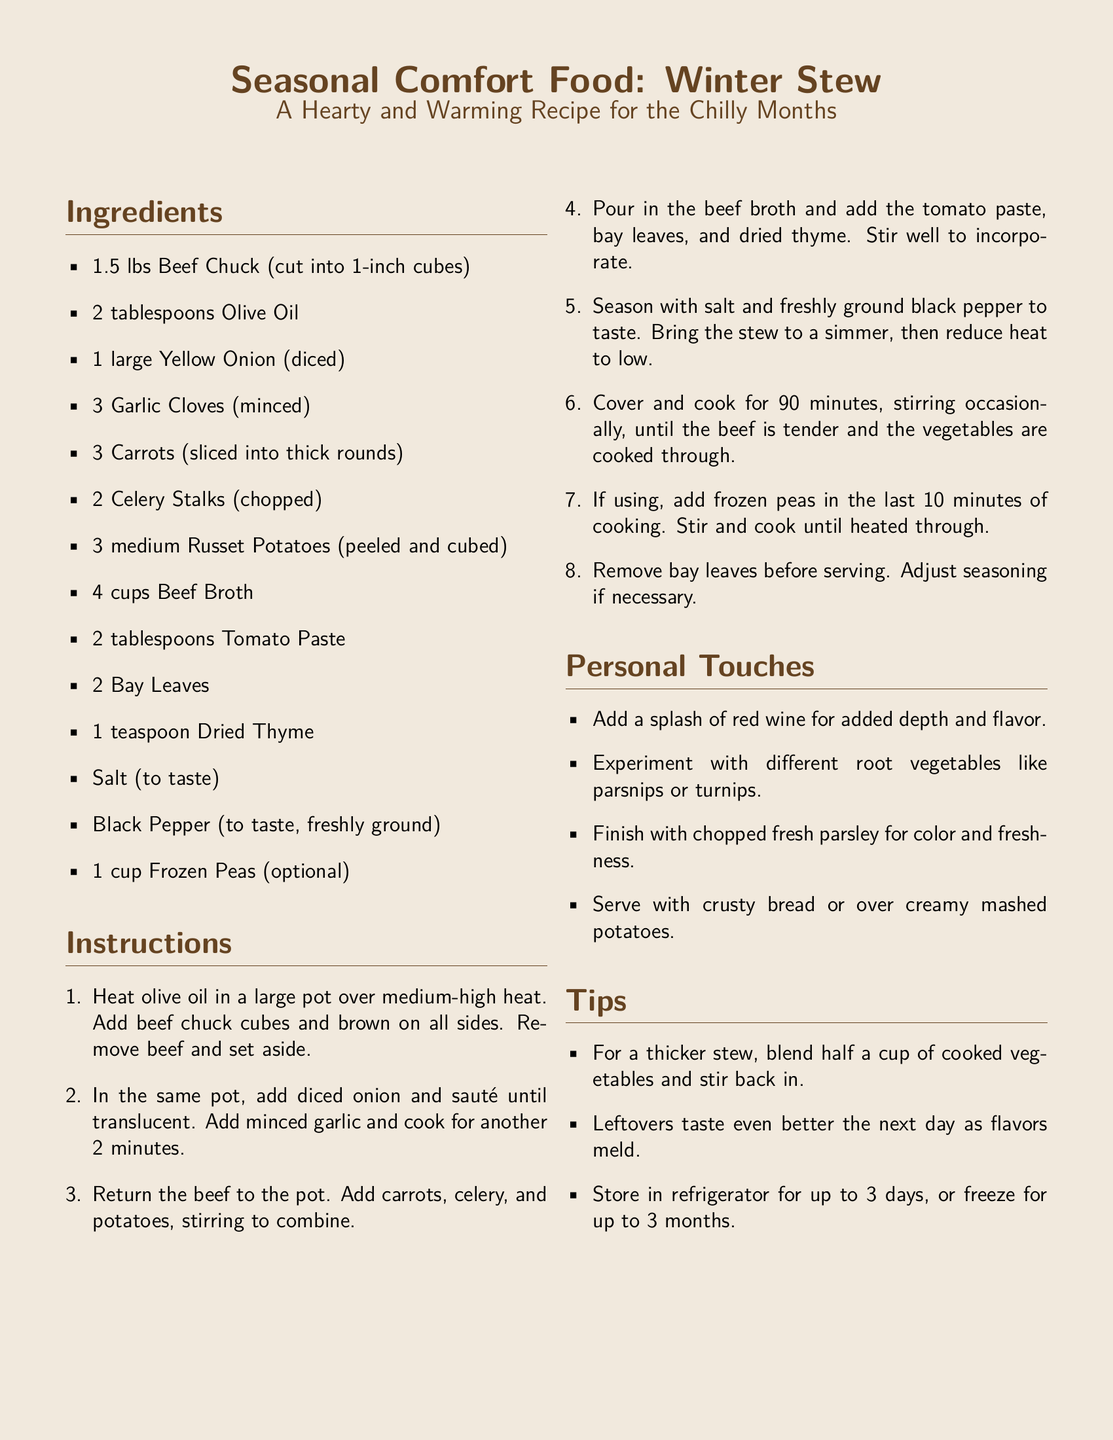What type of meat is used in the stew? The recipe specifies using beef chuck cut into 1-inch cubes.
Answer: Beef Chuck How long does the stew need to cook? The instructions state that the stew should be covered and cooked for 90 minutes.
Answer: 90 minutes What optional ingredient can be added in the last 10 minutes of cooking? The recipe mentions adding frozen peas as an optional ingredient.
Answer: Frozen Peas What is the first step in the cooking instructions? The first step involves heating olive oil in a large pot and browning the beef chuck cubes on all sides.
Answer: Heat olive oil What can be added for extra flavor according to the personal touches section? The personal touches section suggests adding a splash of red wine.
Answer: Red wine What should be done before serving the stew? The instructions indicate that bay leaves should be removed before serving.
Answer: Remove bay leaves How many cups of beef broth are needed? The ingredients list specifies that 4 cups of beef broth are required.
Answer: 4 cups What can be served alongside the stew? The personal touches mention serving the stew with crusty bread or over creamy mashed potatoes.
Answer: Crusty bread What should you do for a thicker stew? The tips section advises blending half a cup of cooked vegetables and stirring it back into the stew.
Answer: Blend cooked vegetables 